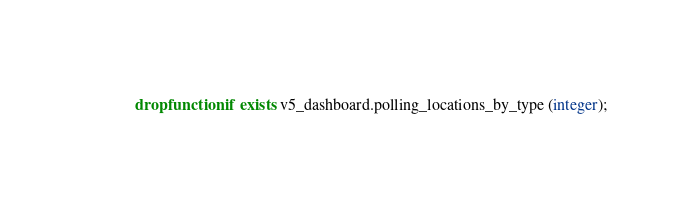<code> <loc_0><loc_0><loc_500><loc_500><_SQL_>drop function if exists v5_dashboard.polling_locations_by_type (integer);
</code> 